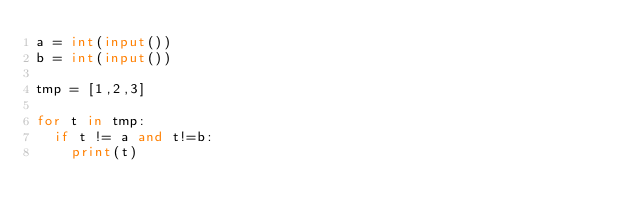<code> <loc_0><loc_0><loc_500><loc_500><_Python_>a = int(input())
b = int(input())

tmp = [1,2,3]

for t in tmp:
  if t != a and t!=b:
    print(t)</code> 